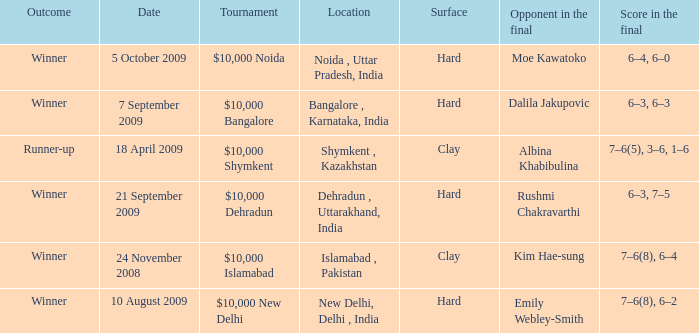What is the name of the tournament where outcome is runner-up $10,000 Shymkent. 